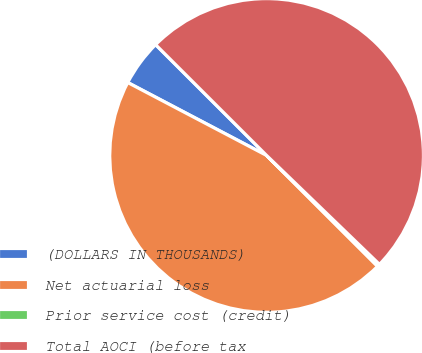Convert chart. <chart><loc_0><loc_0><loc_500><loc_500><pie_chart><fcel>(DOLLARS IN THOUSANDS)<fcel>Net actuarial loss<fcel>Prior service cost (credit)<fcel>Total AOCI (before tax<nl><fcel>4.79%<fcel>45.21%<fcel>0.27%<fcel>49.73%<nl></chart> 